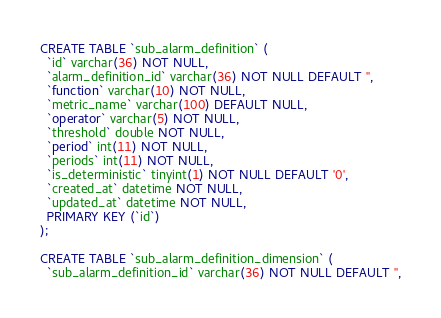Convert code to text. <code><loc_0><loc_0><loc_500><loc_500><_SQL_>
CREATE TABLE `sub_alarm_definition` (
  `id` varchar(36) NOT NULL,
  `alarm_definition_id` varchar(36) NOT NULL DEFAULT '',
  `function` varchar(10) NOT NULL,
  `metric_name` varchar(100) DEFAULT NULL,
  `operator` varchar(5) NOT NULL,
  `threshold` double NOT NULL,
  `period` int(11) NOT NULL,
  `periods` int(11) NOT NULL,
  `is_deterministic` tinyint(1) NOT NULL DEFAULT '0',
  `created_at` datetime NOT NULL,
  `updated_at` datetime NOT NULL,
  PRIMARY KEY (`id`)
);

CREATE TABLE `sub_alarm_definition_dimension` (
  `sub_alarm_definition_id` varchar(36) NOT NULL DEFAULT '',</code> 